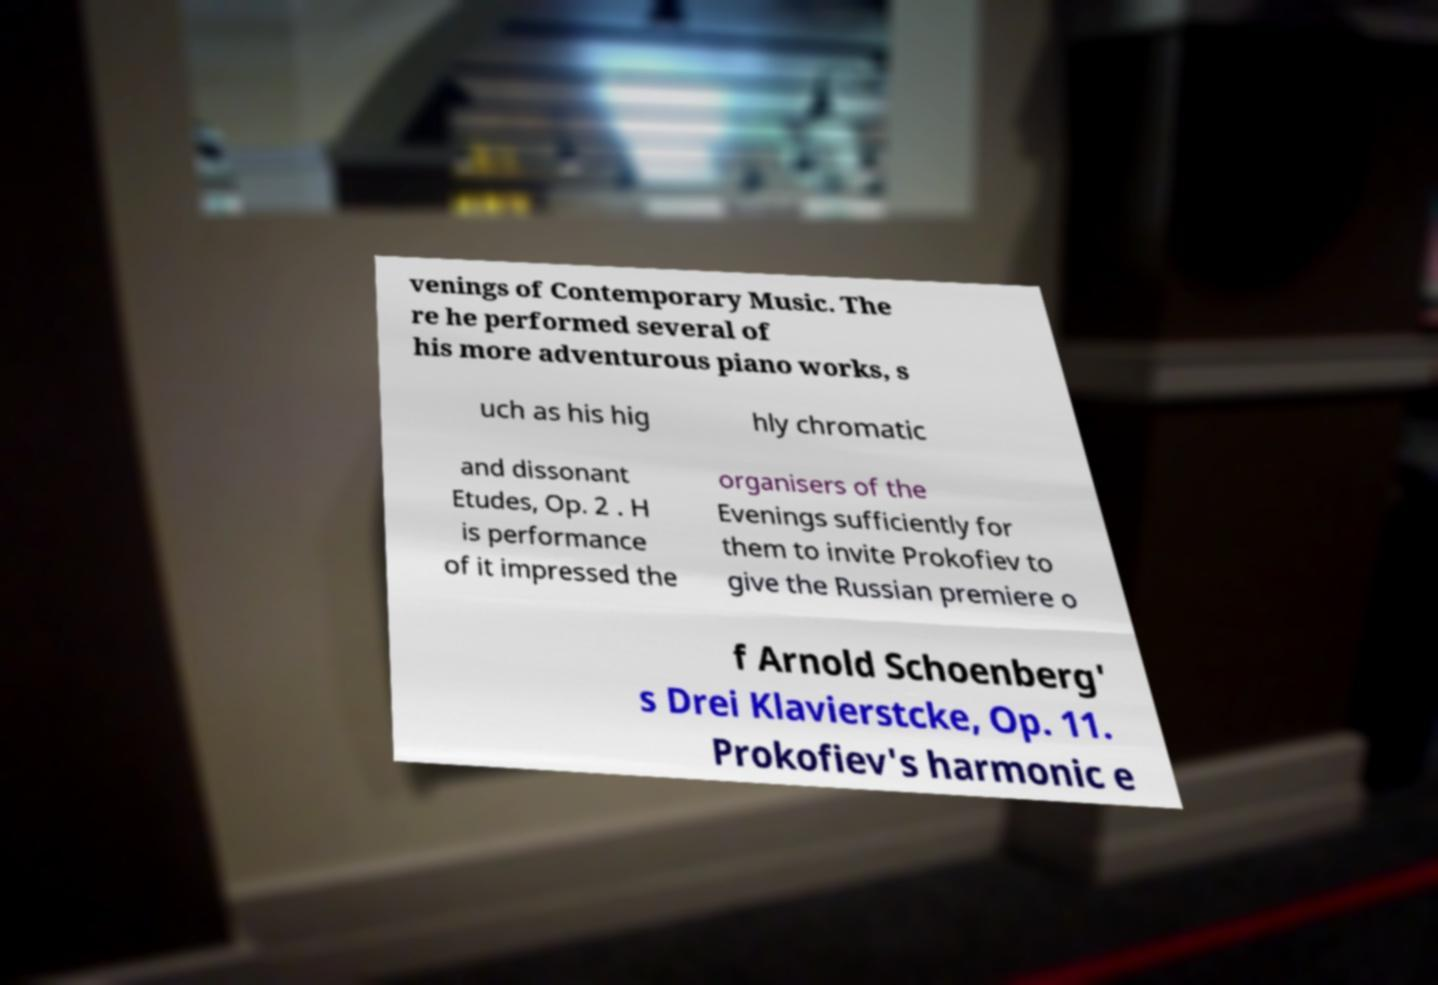For documentation purposes, I need the text within this image transcribed. Could you provide that? venings of Contemporary Music. The re he performed several of his more adventurous piano works, s uch as his hig hly chromatic and dissonant Etudes, Op. 2 . H is performance of it impressed the organisers of the Evenings sufficiently for them to invite Prokofiev to give the Russian premiere o f Arnold Schoenberg' s Drei Klavierstcke, Op. 11. Prokofiev's harmonic e 